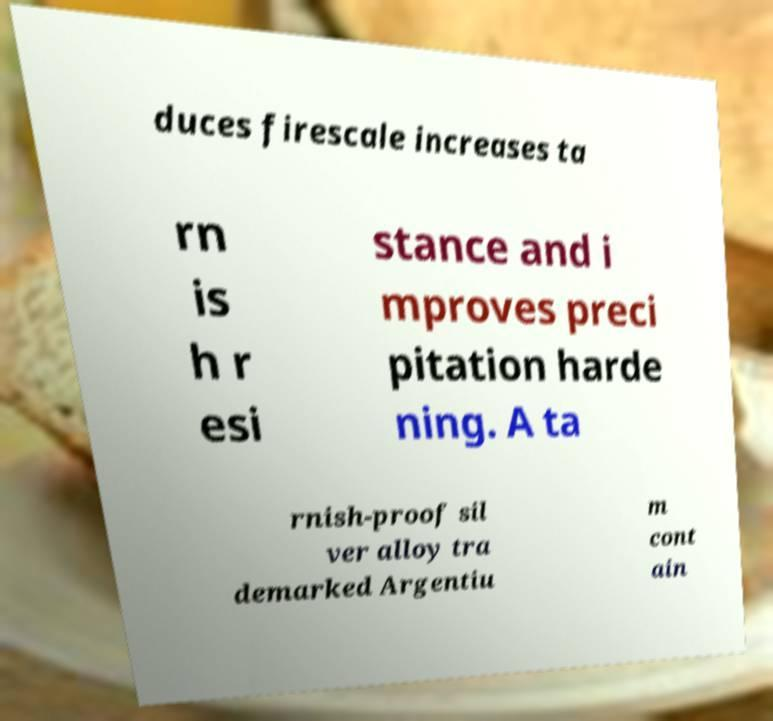Please read and relay the text visible in this image. What does it say? duces firescale increases ta rn is h r esi stance and i mproves preci pitation harde ning. A ta rnish-proof sil ver alloy tra demarked Argentiu m cont ain 